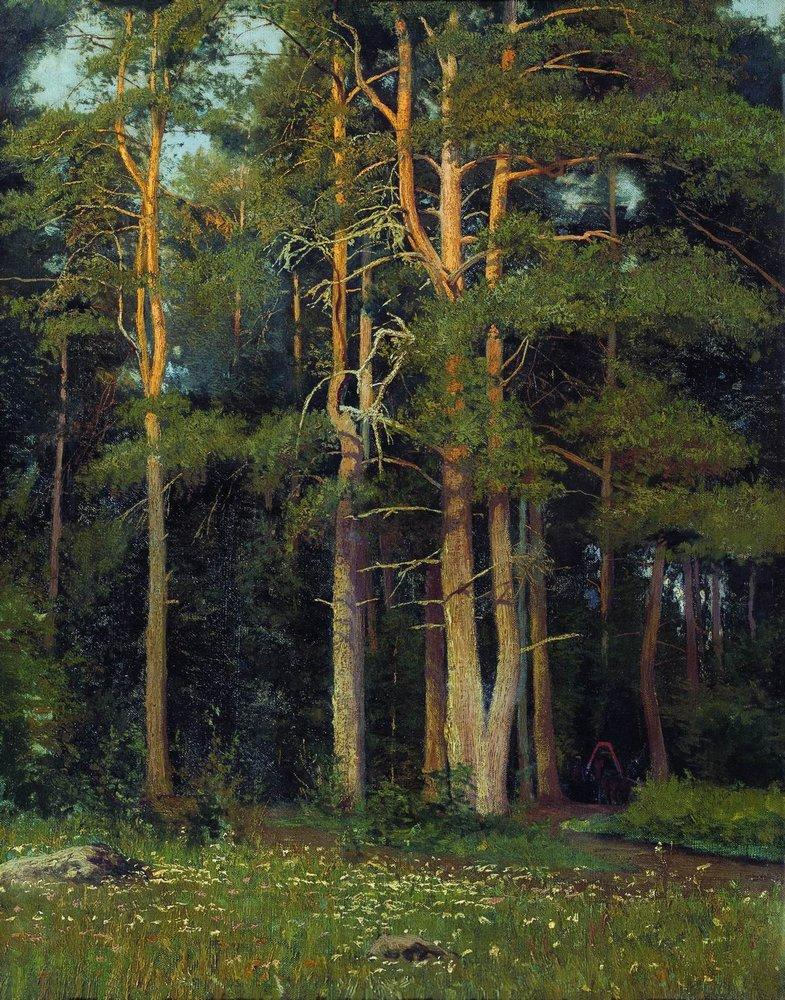What would it feel like to step into this forest? Stepping into this forest would likely be an immersion into tranquility and natural beauty. The air would be filled with the earthy scent of moss and pine, and the soft rustling of leaves would provide a gentle soundtrack. Sunlight filtering through the canopy would create dappled patterns on the forest floor, enhancing the sense of peace and seclusion. You might feel a soft, damp humus beneath your feet and notice the occasional snap of a twig. The environment would invoke a profound sense of connection to nature, far away from the hustle and bustle of everyday life. 